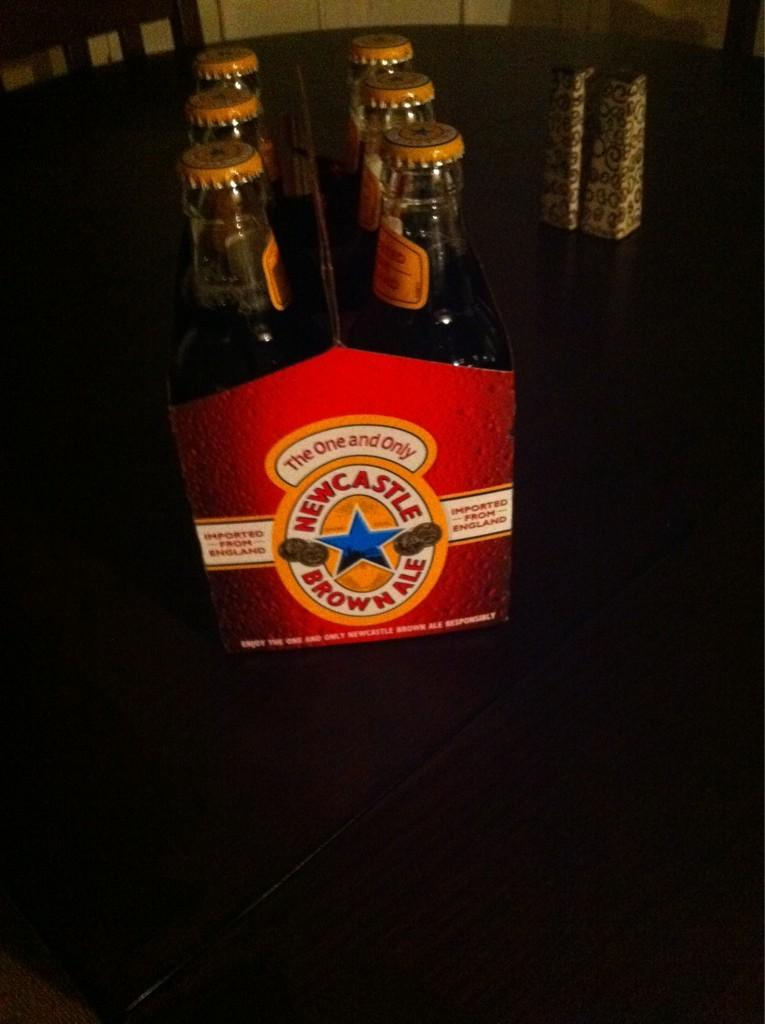<image>
Share a concise interpretation of the image provided. A six pack of Newcastle Brown Ale on a table. 